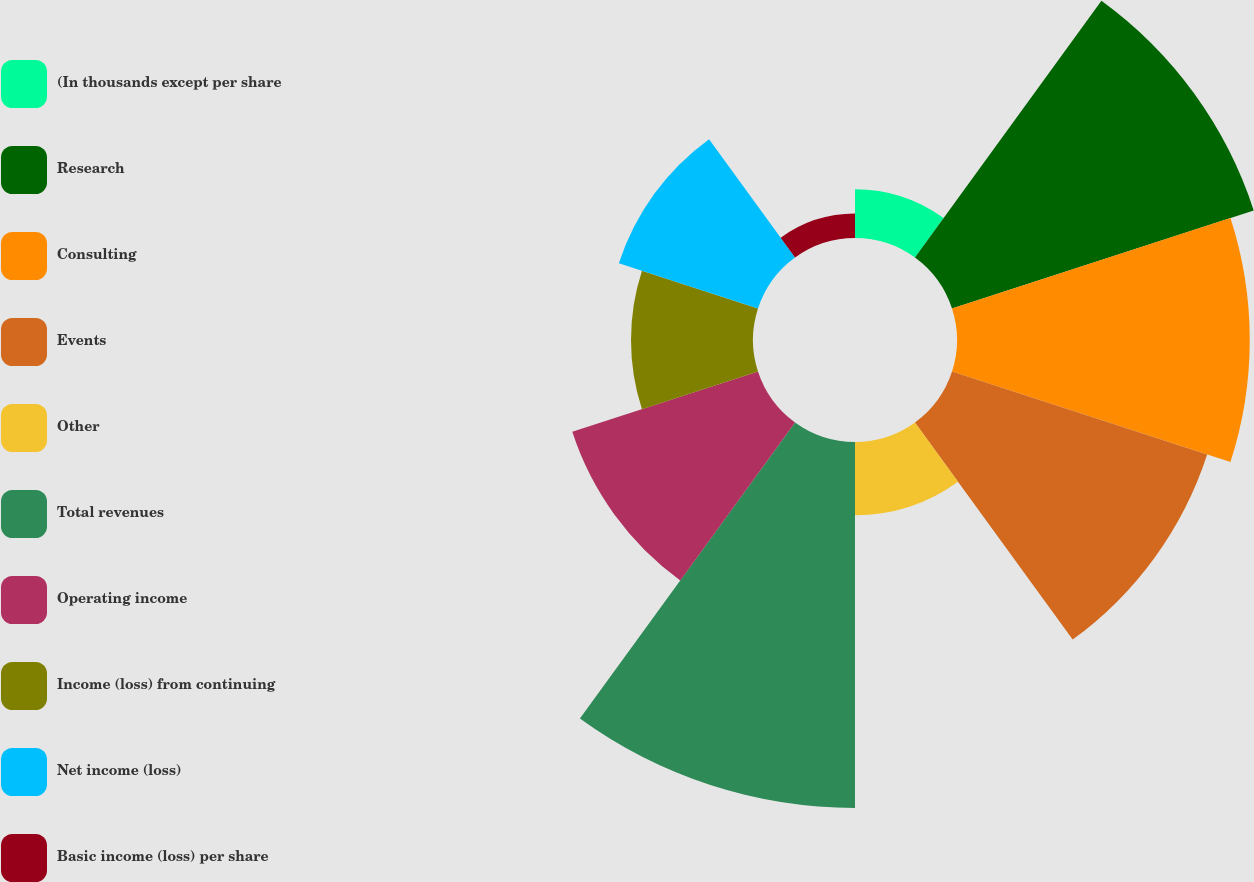Convert chart. <chart><loc_0><loc_0><loc_500><loc_500><pie_chart><fcel>(In thousands except per share<fcel>Research<fcel>Consulting<fcel>Events<fcel>Other<fcel>Total revenues<fcel>Operating income<fcel>Income (loss) from continuing<fcel>Net income (loss)<fcel>Basic income (loss) per share<nl><fcel>2.63%<fcel>17.11%<fcel>15.79%<fcel>14.47%<fcel>3.95%<fcel>19.74%<fcel>10.53%<fcel>6.58%<fcel>7.89%<fcel>1.32%<nl></chart> 